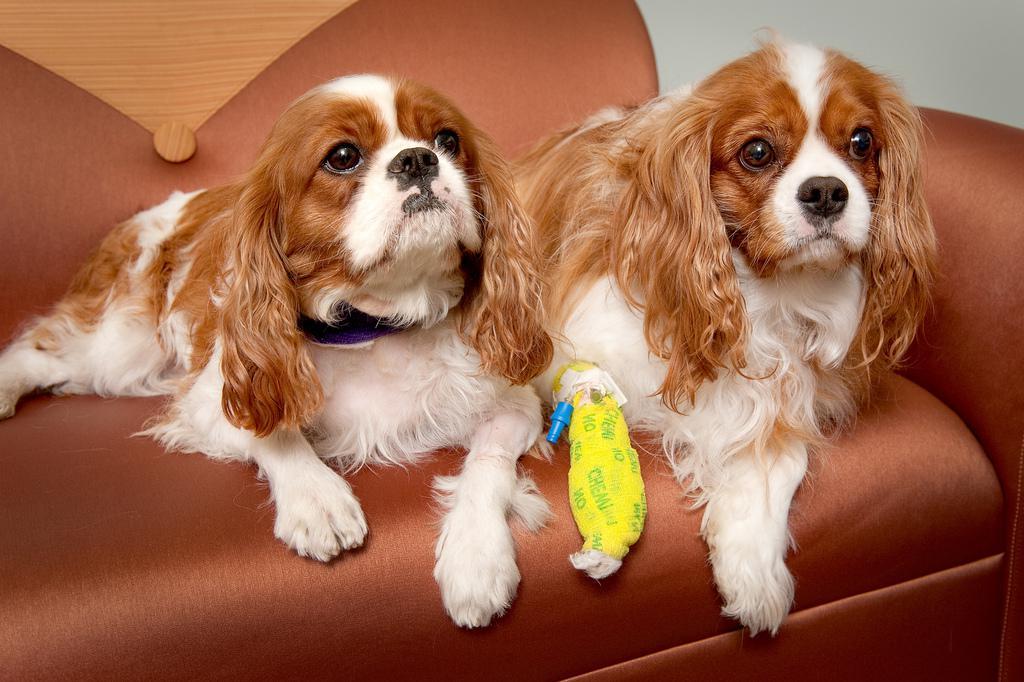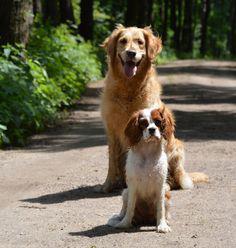The first image is the image on the left, the second image is the image on the right. For the images shown, is this caption "There ar no more than 3 dogs in the image pair" true? Answer yes or no. No. The first image is the image on the left, the second image is the image on the right. Considering the images on both sides, is "There are only three dogs." valid? Answer yes or no. No. 